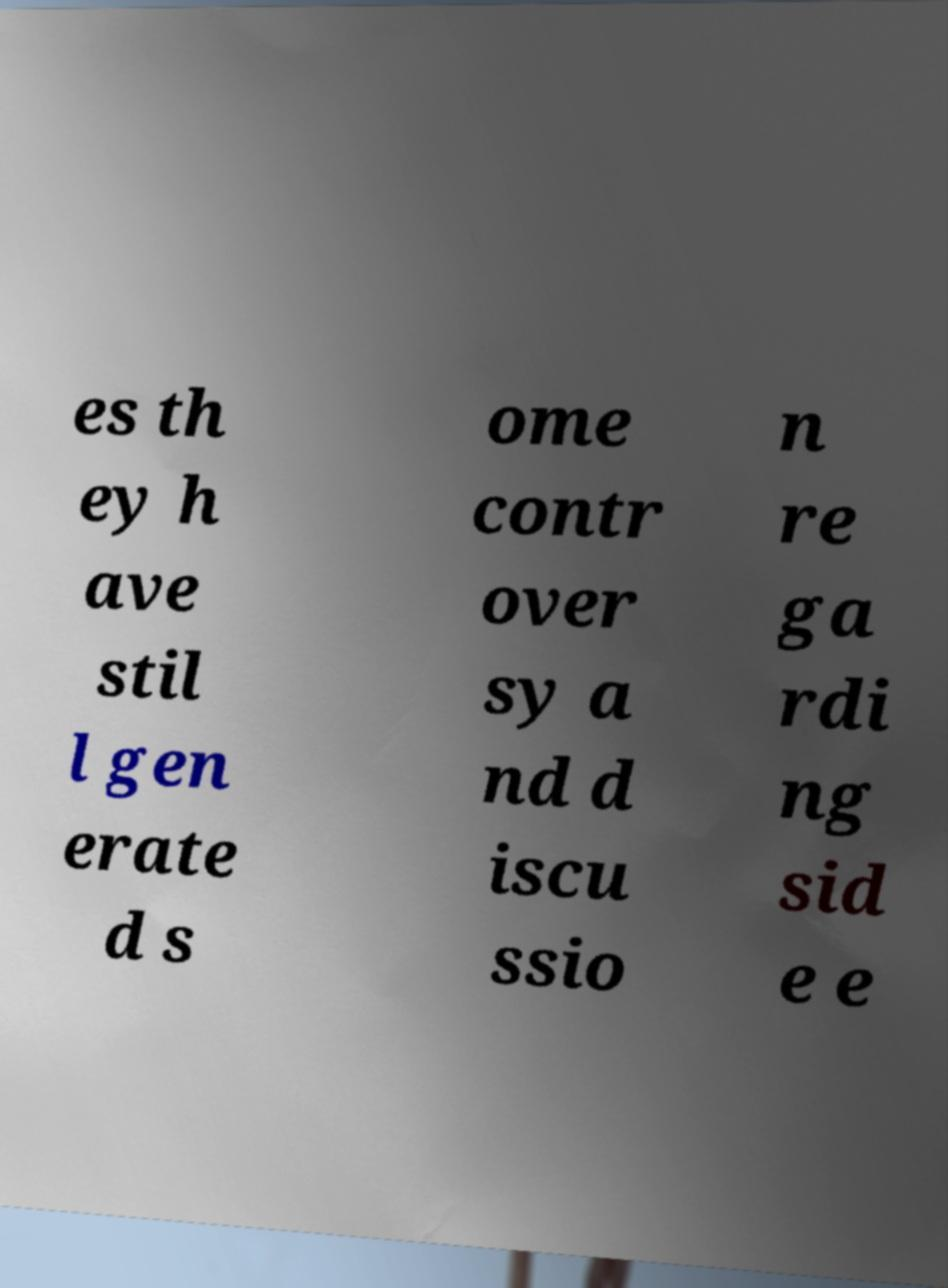Could you extract and type out the text from this image? es th ey h ave stil l gen erate d s ome contr over sy a nd d iscu ssio n re ga rdi ng sid e e 